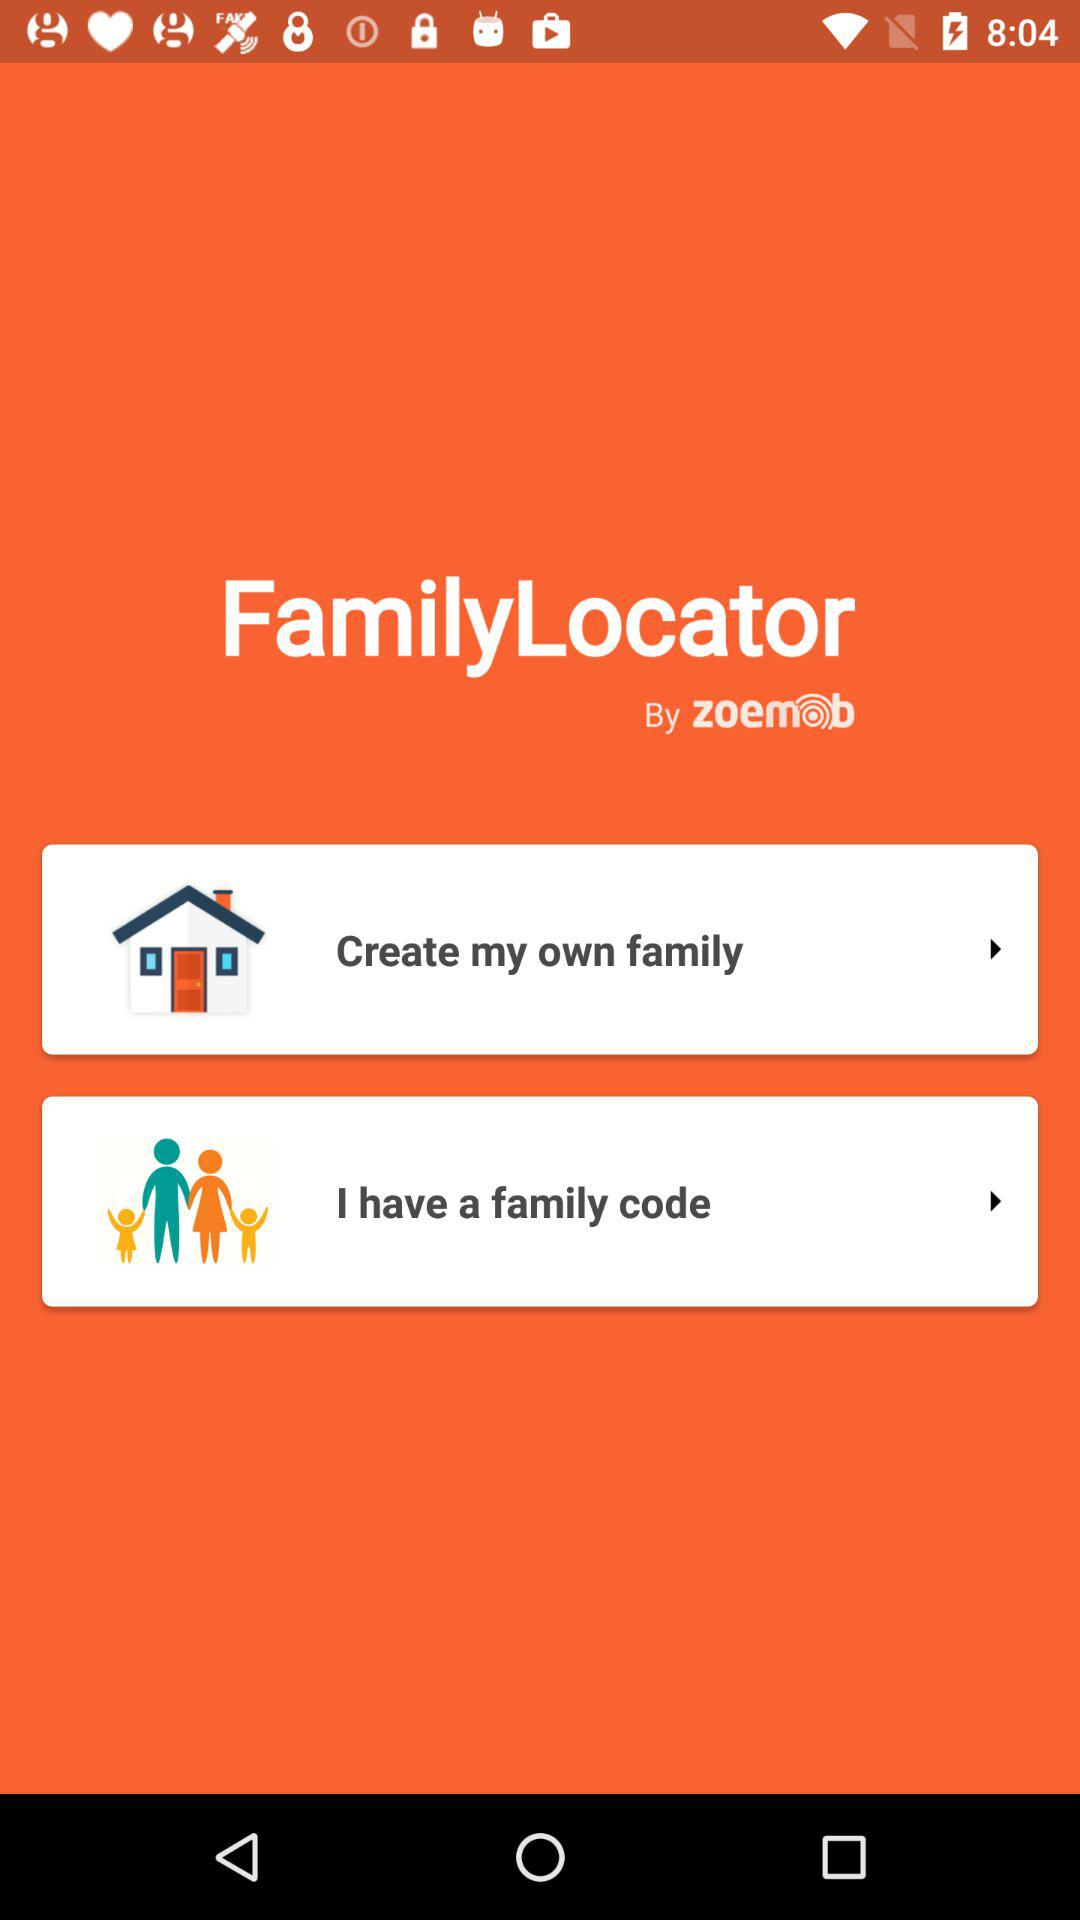What is the app name? The app name is "FamilyLocator". 